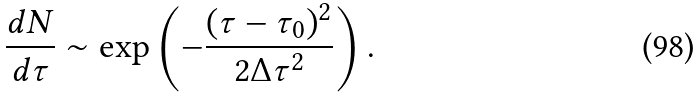Convert formula to latex. <formula><loc_0><loc_0><loc_500><loc_500>\frac { d N } { d \tau } \sim \exp \left ( - \frac { ( \tau - \tau _ { 0 } ) ^ { 2 } } { 2 \Delta \tau ^ { 2 } } \right ) .</formula> 